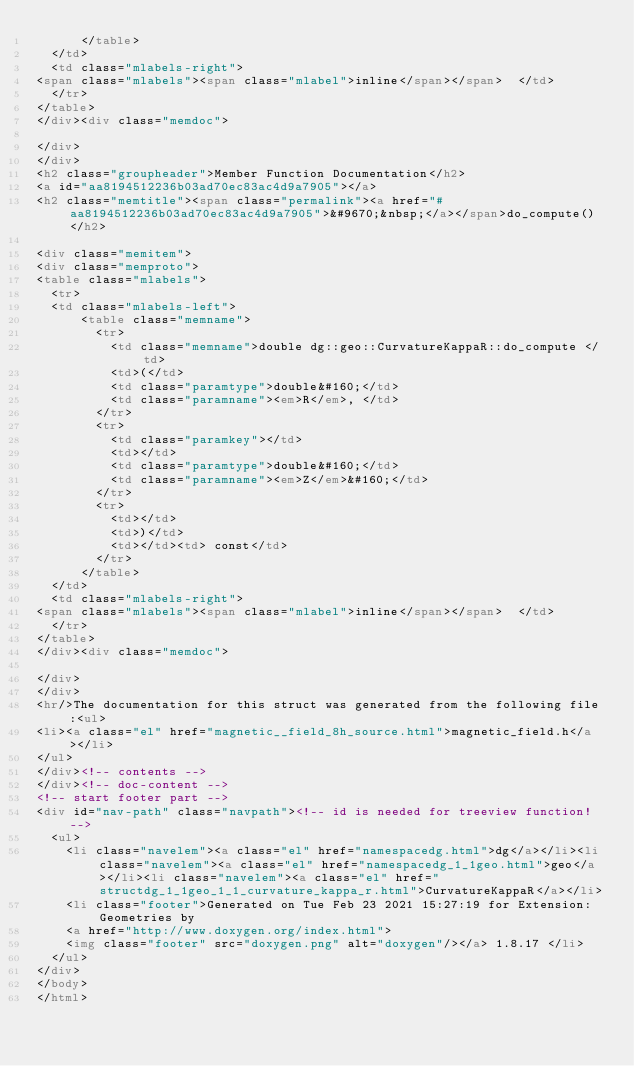<code> <loc_0><loc_0><loc_500><loc_500><_HTML_>      </table>
  </td>
  <td class="mlabels-right">
<span class="mlabels"><span class="mlabel">inline</span></span>  </td>
  </tr>
</table>
</div><div class="memdoc">

</div>
</div>
<h2 class="groupheader">Member Function Documentation</h2>
<a id="aa8194512236b03ad70ec83ac4d9a7905"></a>
<h2 class="memtitle"><span class="permalink"><a href="#aa8194512236b03ad70ec83ac4d9a7905">&#9670;&nbsp;</a></span>do_compute()</h2>

<div class="memitem">
<div class="memproto">
<table class="mlabels">
  <tr>
  <td class="mlabels-left">
      <table class="memname">
        <tr>
          <td class="memname">double dg::geo::CurvatureKappaR::do_compute </td>
          <td>(</td>
          <td class="paramtype">double&#160;</td>
          <td class="paramname"><em>R</em>, </td>
        </tr>
        <tr>
          <td class="paramkey"></td>
          <td></td>
          <td class="paramtype">double&#160;</td>
          <td class="paramname"><em>Z</em>&#160;</td>
        </tr>
        <tr>
          <td></td>
          <td>)</td>
          <td></td><td> const</td>
        </tr>
      </table>
  </td>
  <td class="mlabels-right">
<span class="mlabels"><span class="mlabel">inline</span></span>  </td>
  </tr>
</table>
</div><div class="memdoc">

</div>
</div>
<hr/>The documentation for this struct was generated from the following file:<ul>
<li><a class="el" href="magnetic__field_8h_source.html">magnetic_field.h</a></li>
</ul>
</div><!-- contents -->
</div><!-- doc-content -->
<!-- start footer part -->
<div id="nav-path" class="navpath"><!-- id is needed for treeview function! -->
  <ul>
    <li class="navelem"><a class="el" href="namespacedg.html">dg</a></li><li class="navelem"><a class="el" href="namespacedg_1_1geo.html">geo</a></li><li class="navelem"><a class="el" href="structdg_1_1geo_1_1_curvature_kappa_r.html">CurvatureKappaR</a></li>
    <li class="footer">Generated on Tue Feb 23 2021 15:27:19 for Extension: Geometries by
    <a href="http://www.doxygen.org/index.html">
    <img class="footer" src="doxygen.png" alt="doxygen"/></a> 1.8.17 </li>
  </ul>
</div>
</body>
</html>
</code> 